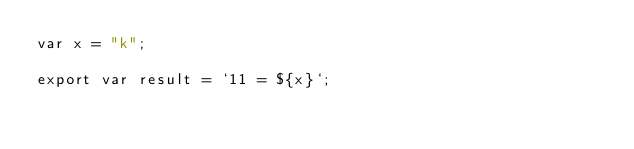<code> <loc_0><loc_0><loc_500><loc_500><_JavaScript_>var x = "k";

export var result = `11 = ${x}`;</code> 